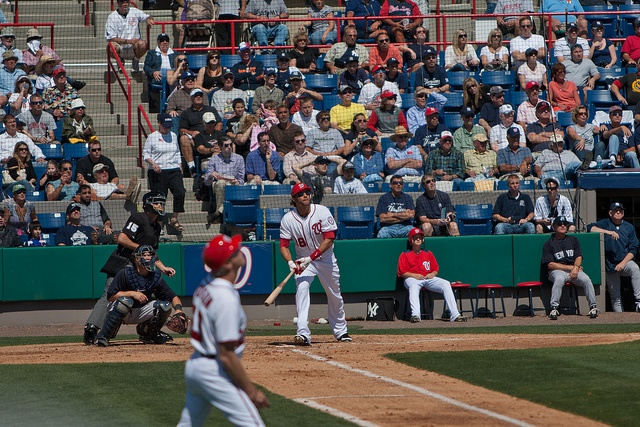Describe the objects in this image and their specific colors. I can see people in lightgray, darkgray, gray, and black tones, people in lightgray, gray, darkgray, and black tones, people in lightgray, black, gray, maroon, and navy tones, chair in lightgray, blue, navy, and black tones, and people in lightgray, black, gray, brown, and maroon tones in this image. 